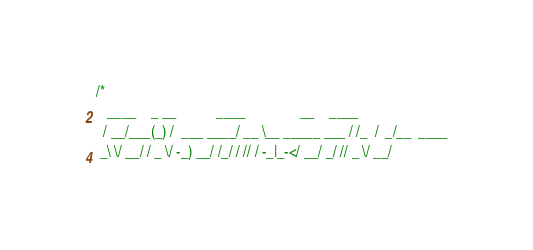<code> <loc_0><loc_0><loc_500><loc_500><_C_>/*
   ____    _ __           ____               __    ____
  / __/___(_) /  ___ ____/ __ \__ _____ ___ / /_  /  _/__  ____
 _\ \/ __/ / _ \/ -_) __/ /_/ / // / -_|_-</ __/ _/ // _ \/ __/</code> 